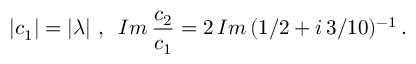<formula> <loc_0><loc_0><loc_500><loc_500>| c _ { 1 } | = | \lambda | \, , \, I m \, \frac { c _ { 2 } } { c _ { 1 } } = 2 \, I m \, ( 1 / 2 + i \, 3 / 1 0 ) ^ { - 1 } \, .</formula> 